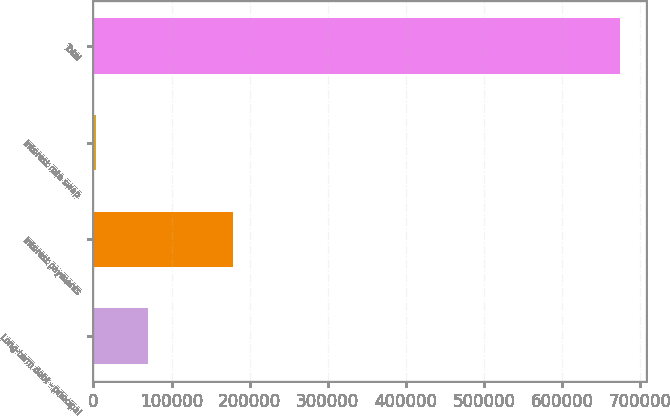Convert chart to OTSL. <chart><loc_0><loc_0><loc_500><loc_500><bar_chart><fcel>Long-term debt - principal<fcel>Interest payments<fcel>Interest rate swap<fcel>Total<nl><fcel>70122.8<fcel>178777<fcel>3009<fcel>674147<nl></chart> 